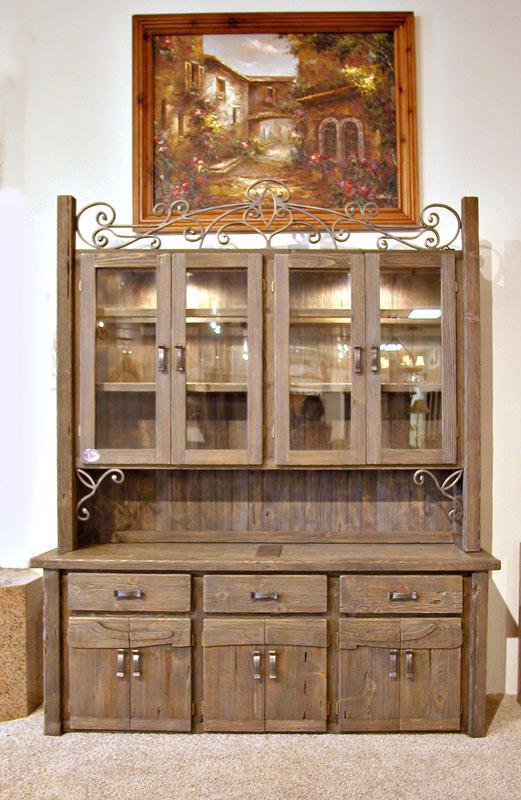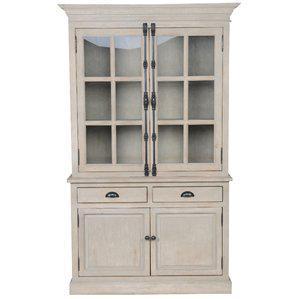The first image is the image on the left, the second image is the image on the right. Examine the images to the left and right. Is the description "All cabinets shown are rich brown wood tones." accurate? Answer yes or no. No. 